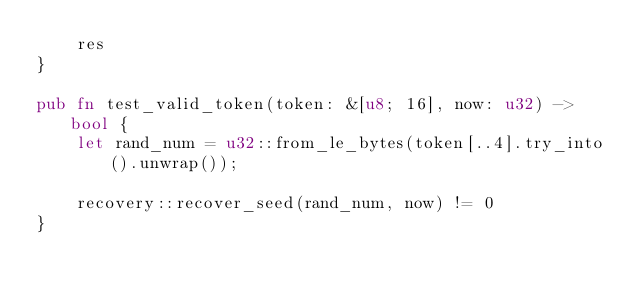Convert code to text. <code><loc_0><loc_0><loc_500><loc_500><_Rust_>    res
}

pub fn test_valid_token(token: &[u8; 16], now: u32) -> bool {
    let rand_num = u32::from_le_bytes(token[..4].try_into().unwrap());

    recovery::recover_seed(rand_num, now) != 0
}
</code> 